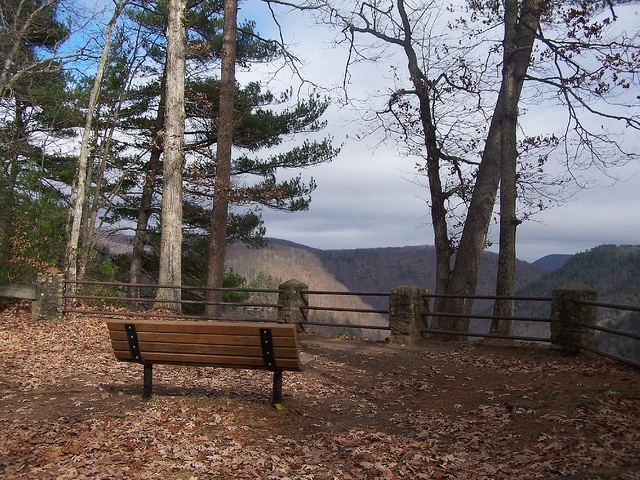Describe the objects in this image and their specific colors. I can see a bench in black, maroon, and gray tones in this image. 